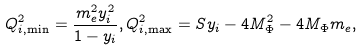<formula> <loc_0><loc_0><loc_500><loc_500>Q ^ { 2 } _ { i , \min } = \frac { m _ { e } ^ { 2 } y _ { i } ^ { 2 } } { 1 - y _ { i } } , Q ^ { 2 } _ { i , \max } = S y _ { i } - 4 M ^ { 2 } _ { \Phi } - 4 M _ { \Phi } m _ { e } ,</formula> 